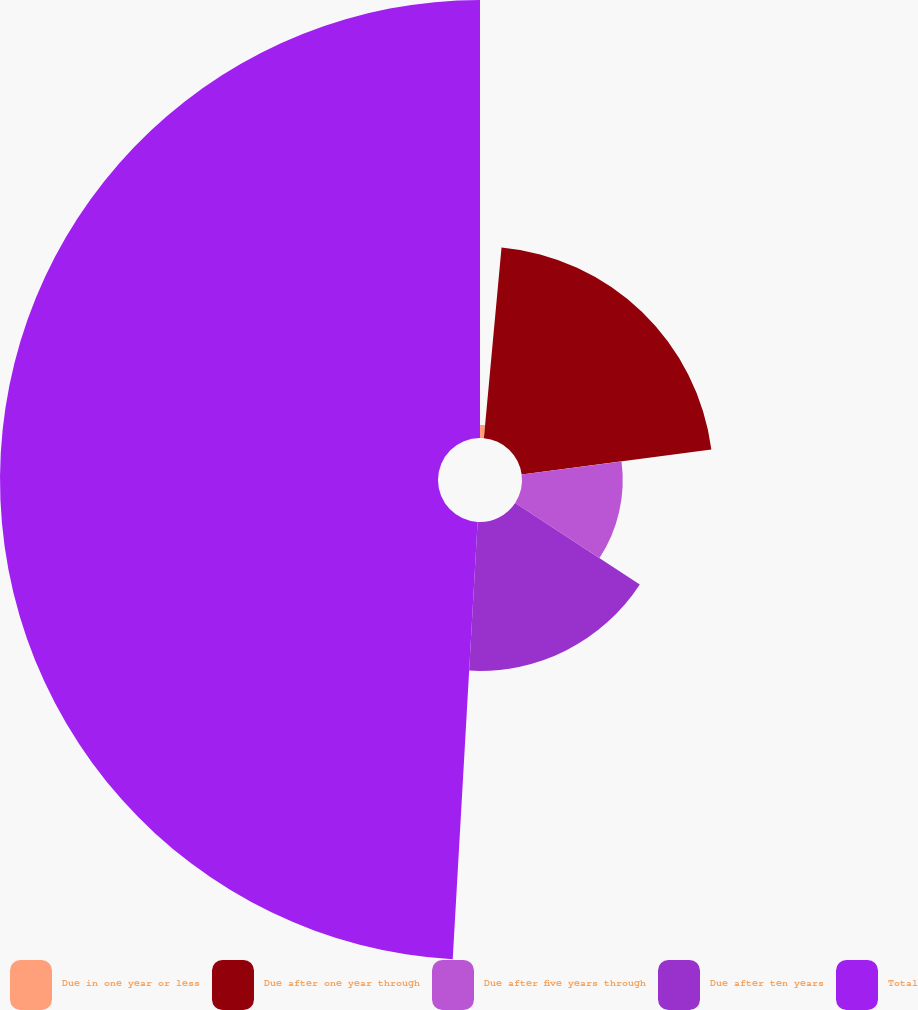Convert chart to OTSL. <chart><loc_0><loc_0><loc_500><loc_500><pie_chart><fcel>Due in one year or less<fcel>Due after one year through<fcel>Due after five years through<fcel>Due after ten years<fcel>Total<nl><fcel>1.47%<fcel>21.45%<fcel>11.29%<fcel>16.69%<fcel>49.09%<nl></chart> 